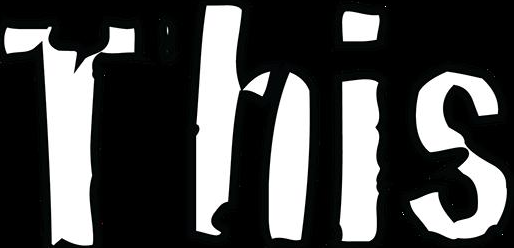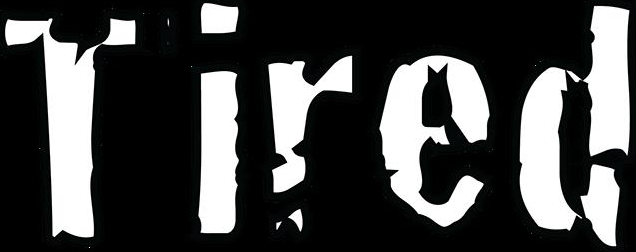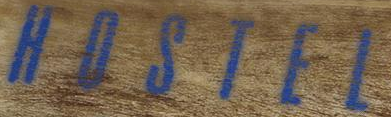Read the text content from these images in order, separated by a semicolon. This; Tired; HOSTEL 